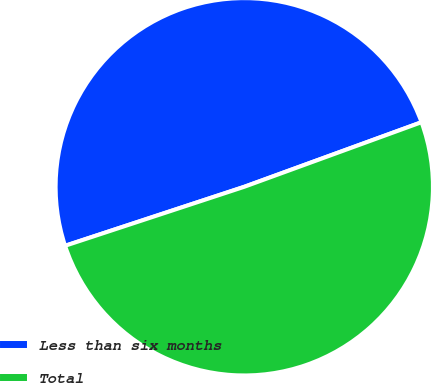Convert chart to OTSL. <chart><loc_0><loc_0><loc_500><loc_500><pie_chart><fcel>Less than six months<fcel>Total<nl><fcel>49.5%<fcel>50.5%<nl></chart> 